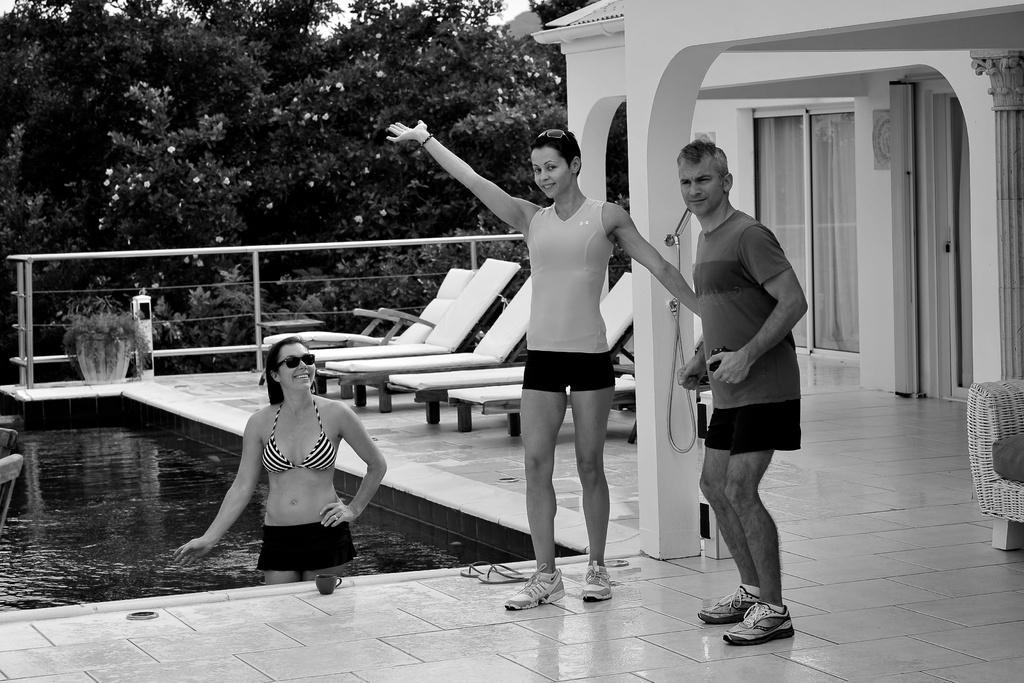In one or two sentences, can you explain what this image depicts? In this image I can see a woman is in the water. Here I can see a man and a woman are standing on the floor. Here I can see water, chairs, pillars and fence. Here I can see a house, trees and some other objects on the floor. This picture is black and white in color. 